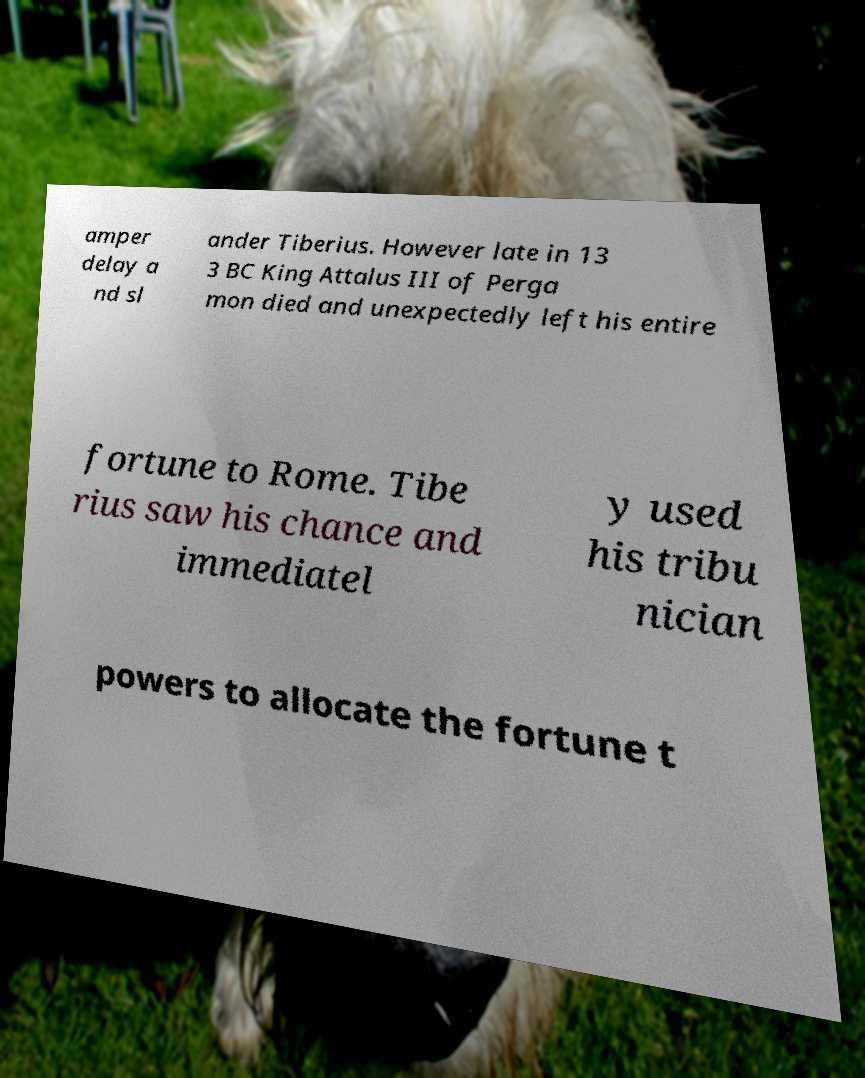What messages or text are displayed in this image? I need them in a readable, typed format. amper delay a nd sl ander Tiberius. However late in 13 3 BC King Attalus III of Perga mon died and unexpectedly left his entire fortune to Rome. Tibe rius saw his chance and immediatel y used his tribu nician powers to allocate the fortune t 